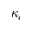<formula> <loc_0><loc_0><loc_500><loc_500>\kappa _ { c }</formula> 